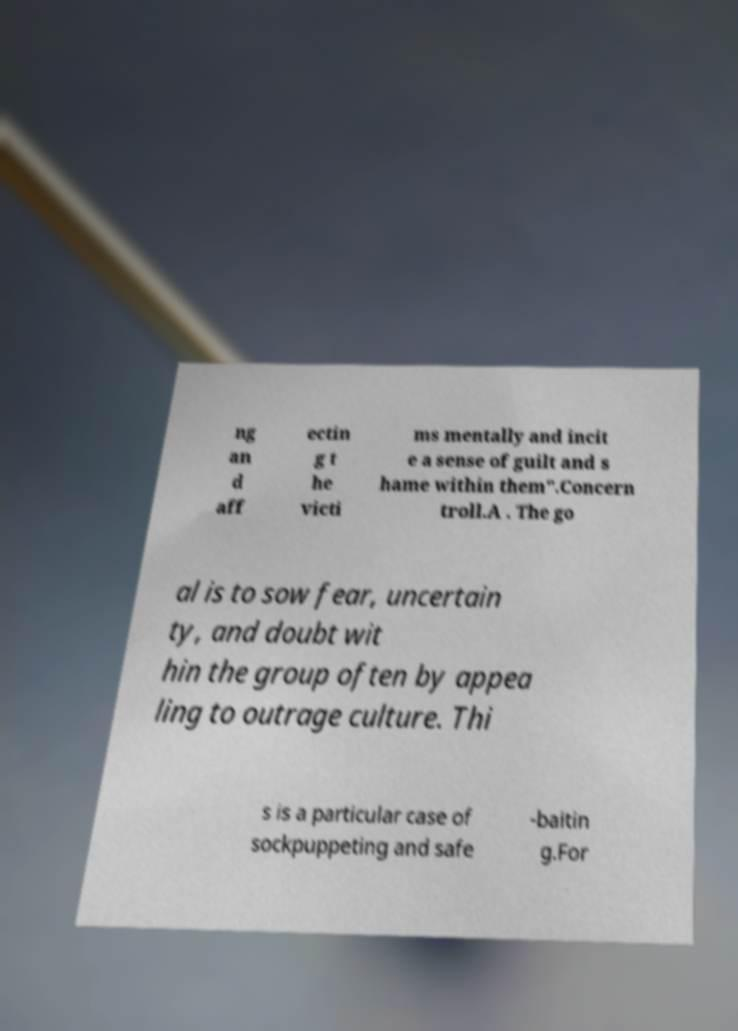I need the written content from this picture converted into text. Can you do that? ng an d aff ectin g t he victi ms mentally and incit e a sense of guilt and s hame within them".Concern troll.A . The go al is to sow fear, uncertain ty, and doubt wit hin the group often by appea ling to outrage culture. Thi s is a particular case of sockpuppeting and safe -baitin g.For 